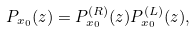Convert formula to latex. <formula><loc_0><loc_0><loc_500><loc_500>P _ { x _ { 0 } } ( z ) = P _ { x _ { 0 } } ^ { ( R ) } ( z ) P _ { x _ { 0 } } ^ { ( L ) } ( z ) ,</formula> 